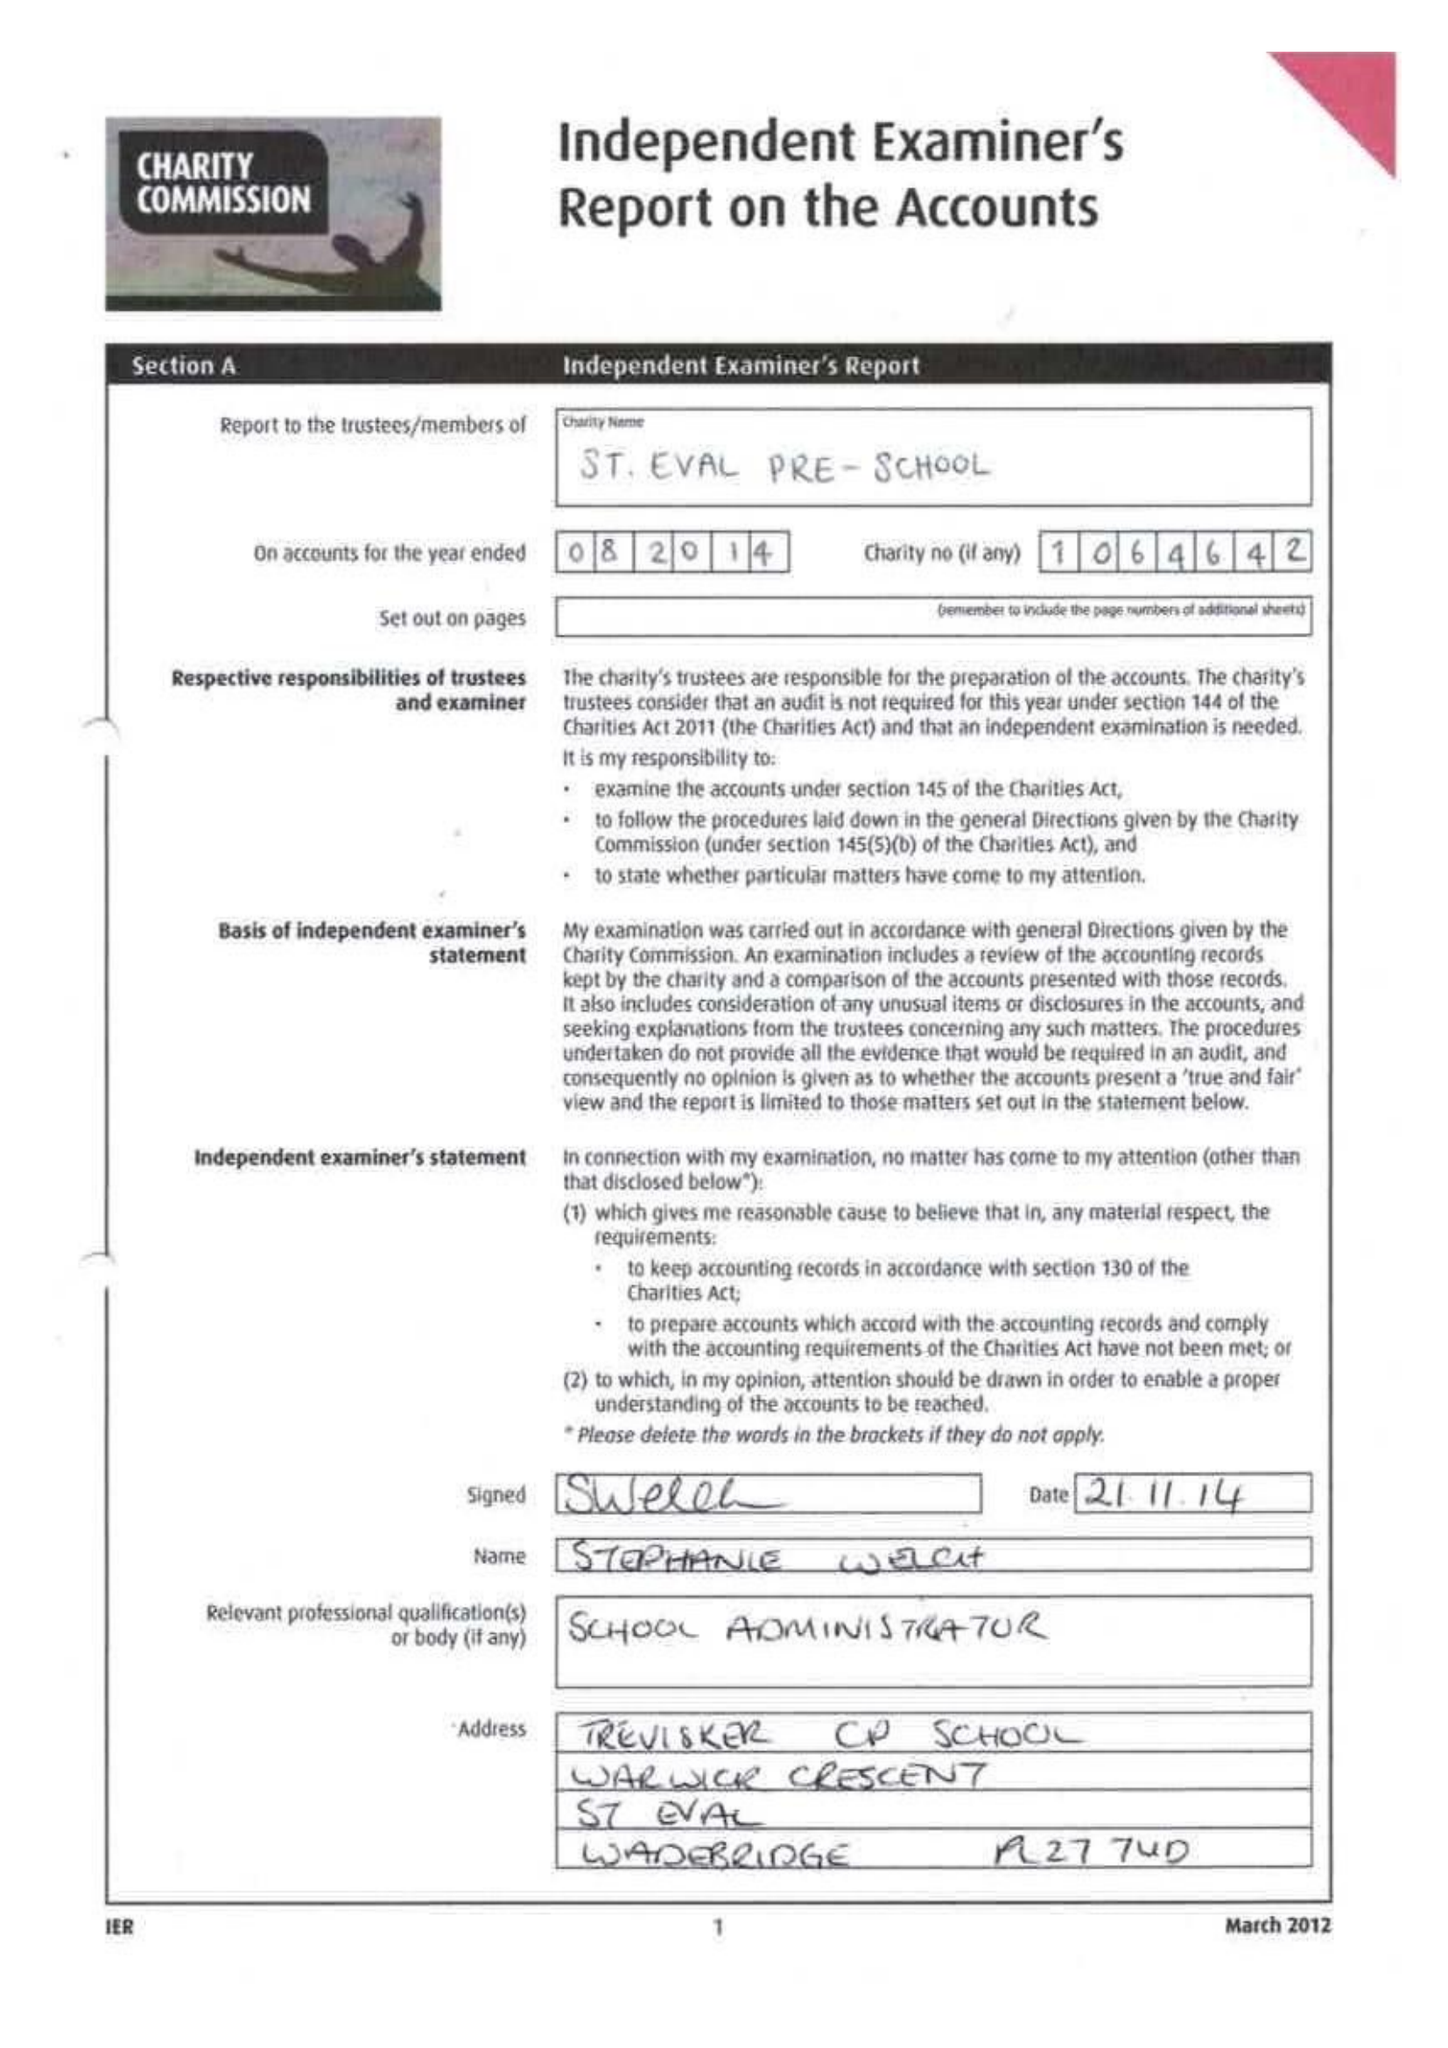What is the value for the address__postcode?
Answer the question using a single word or phrase. PL27 7TR 